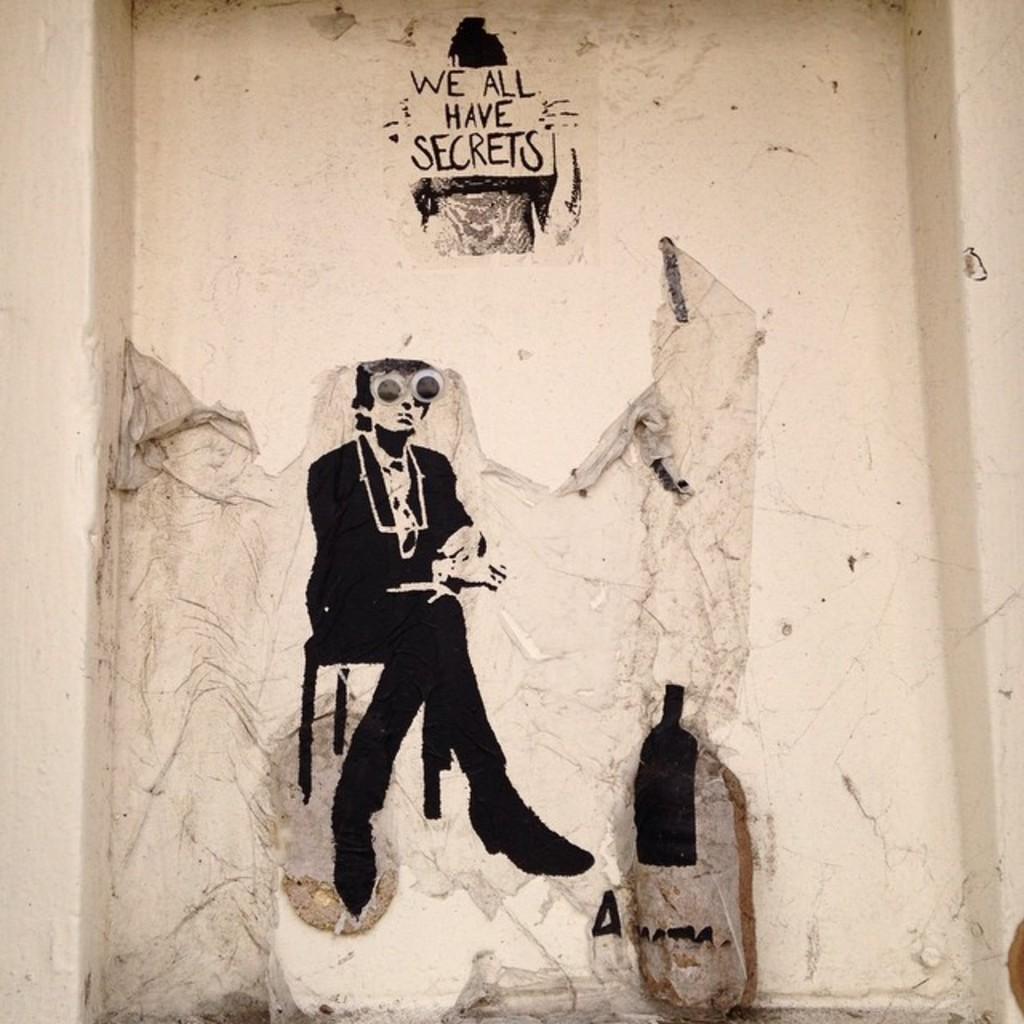Can you describe this image briefly? In the image there is a wall and there are some paintings on the wall and there is also a quotation painted on the wall. 